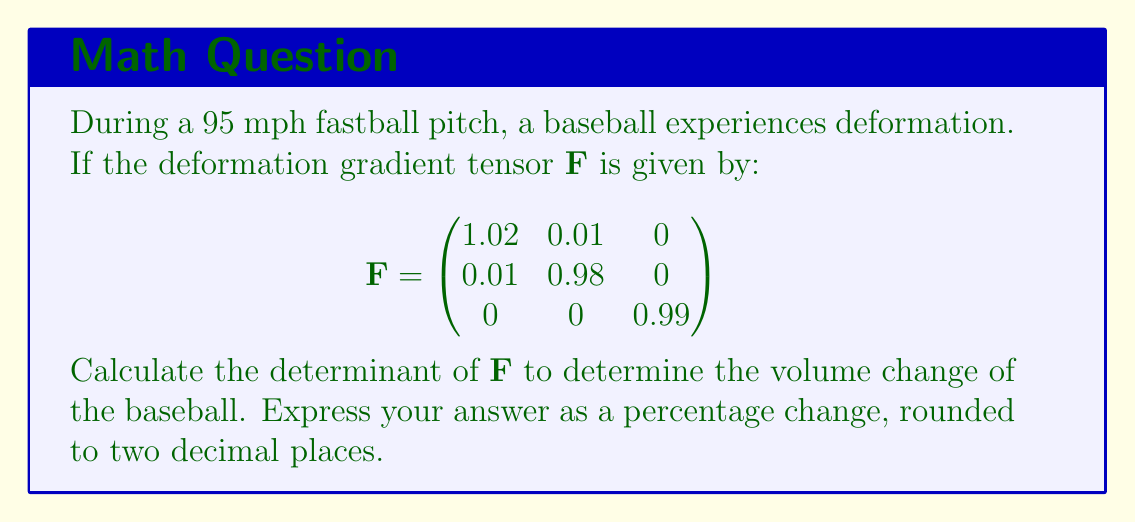Solve this math problem. To solve this problem, we'll follow these steps:

1) The determinant of the deformation gradient tensor $\mathbf{F}$ represents the volume change of the object. If $det(\mathbf{F}) > 1$, the volume increases; if $det(\mathbf{F}) < 1$, the volume decreases.

2) For a 3x3 matrix, the determinant is calculated as:

   $$det(\mathbf{F}) = a_{11}(a_{22}a_{33} - a_{23}a_{32}) - a_{12}(a_{21}a_{33} - a_{23}a_{31}) + a_{13}(a_{21}a_{32} - a_{22}a_{31})$$

3) Substituting the values from our matrix:

   $$det(\mathbf{F}) = 1.02((0.98)(0.99) - 0 \cdot 0) - 0.01((0.01)(0.99) - 0 \cdot 0) + 0(0.01 \cdot 0 - 0.98 \cdot 0)$$

4) Simplifying:

   $$det(\mathbf{F}) = 1.02(0.9702) - 0.01(0.0099) + 0$$
   $$det(\mathbf{F}) = 0.989604 - 0.000099$$
   $$det(\mathbf{F}) = 0.989505$$

5) To express this as a percentage change:

   Percentage change = $(det(\mathbf{F}) - 1) \times 100\%$
   $= (0.989505 - 1) \times 100\%$
   $= -0.01049505 \times 100\%$
   $= -1.049505\%$

6) Rounding to two decimal places: -1.05%

This negative value indicates a decrease in volume.
Answer: -1.05% 